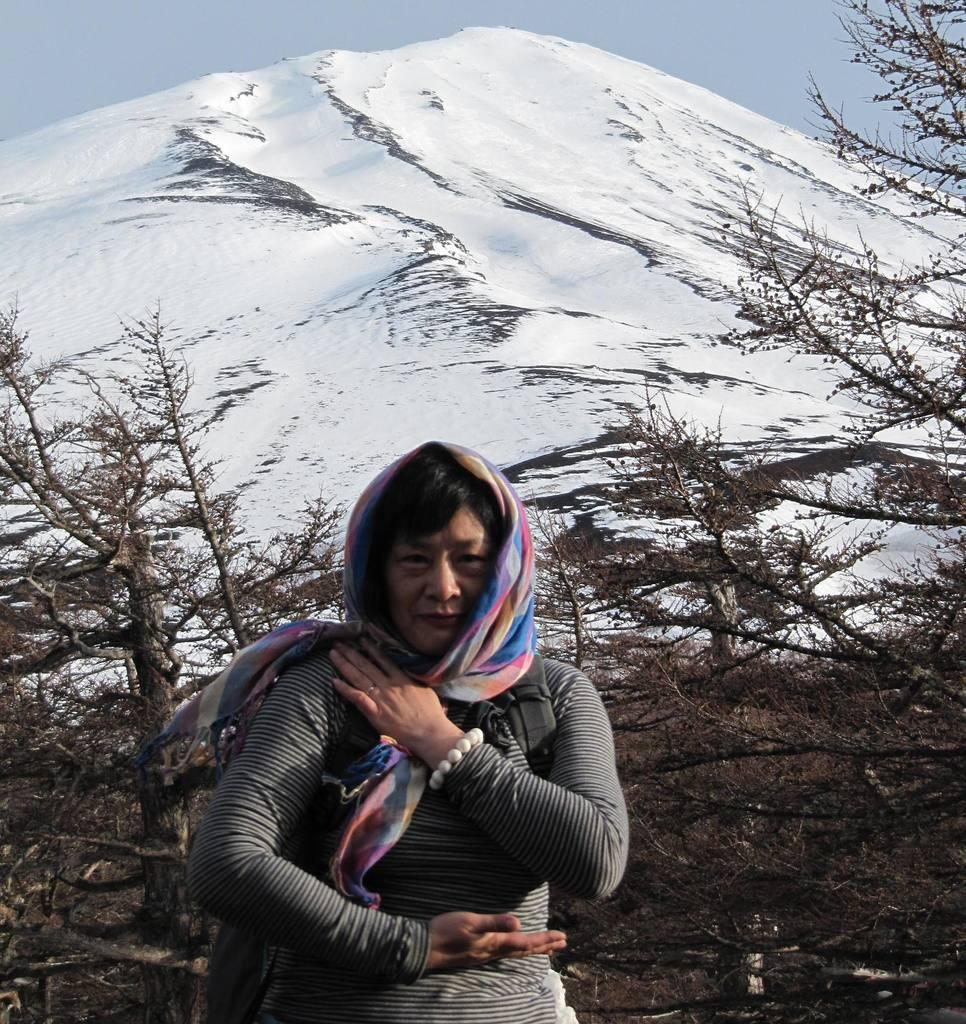Who is present in the image? There is a person at the bottom of the image. What is the person wearing? The person is wearing a scarf. What is the person's facial expression? The person is smiling. What can be seen in the background of the image? There are trees and a mountain in the background of the image. What is the condition of the mountain? The mountain has snow on it. What is visible in the sky? There are clouds in the sky. Where is the lift located in the image? There is no lift present in the image. What does the person need to do in order to enter the cave? There is no cave present in the image, so the person does not need to do anything related to a cave. 